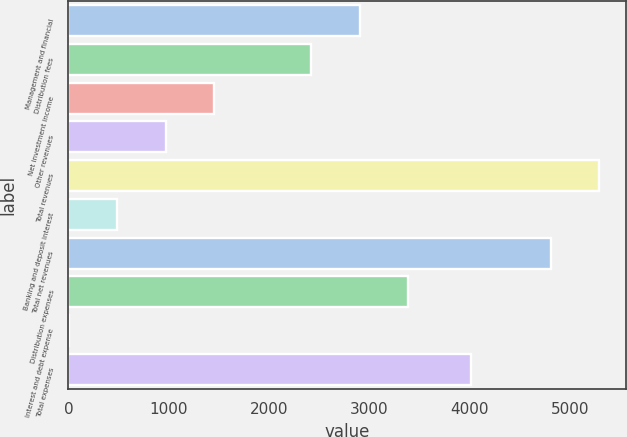Convert chart. <chart><loc_0><loc_0><loc_500><loc_500><bar_chart><fcel>Management and financial<fcel>Distribution fees<fcel>Net investment income<fcel>Other revenues<fcel>Total revenues<fcel>Banking and deposit interest<fcel>Total net revenues<fcel>Distribution expenses<fcel>Interest and debt expense<fcel>Total expenses<nl><fcel>2902.8<fcel>2420<fcel>1454.4<fcel>971.6<fcel>5288.8<fcel>488.8<fcel>4806<fcel>3385.6<fcel>6<fcel>4014<nl></chart> 